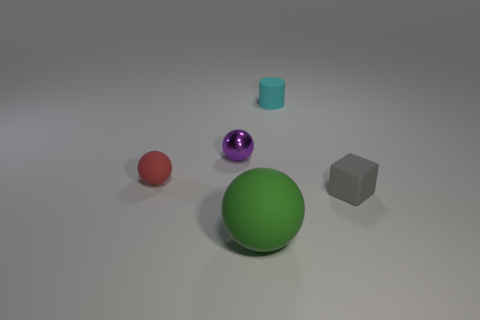Add 4 cyan objects. How many objects exist? 9 Subtract all cylinders. How many objects are left? 4 Subtract 0 cyan cubes. How many objects are left? 5 Subtract all rubber blocks. Subtract all large matte things. How many objects are left? 3 Add 4 purple balls. How many purple balls are left? 5 Add 1 tiny green matte cubes. How many tiny green matte cubes exist? 1 